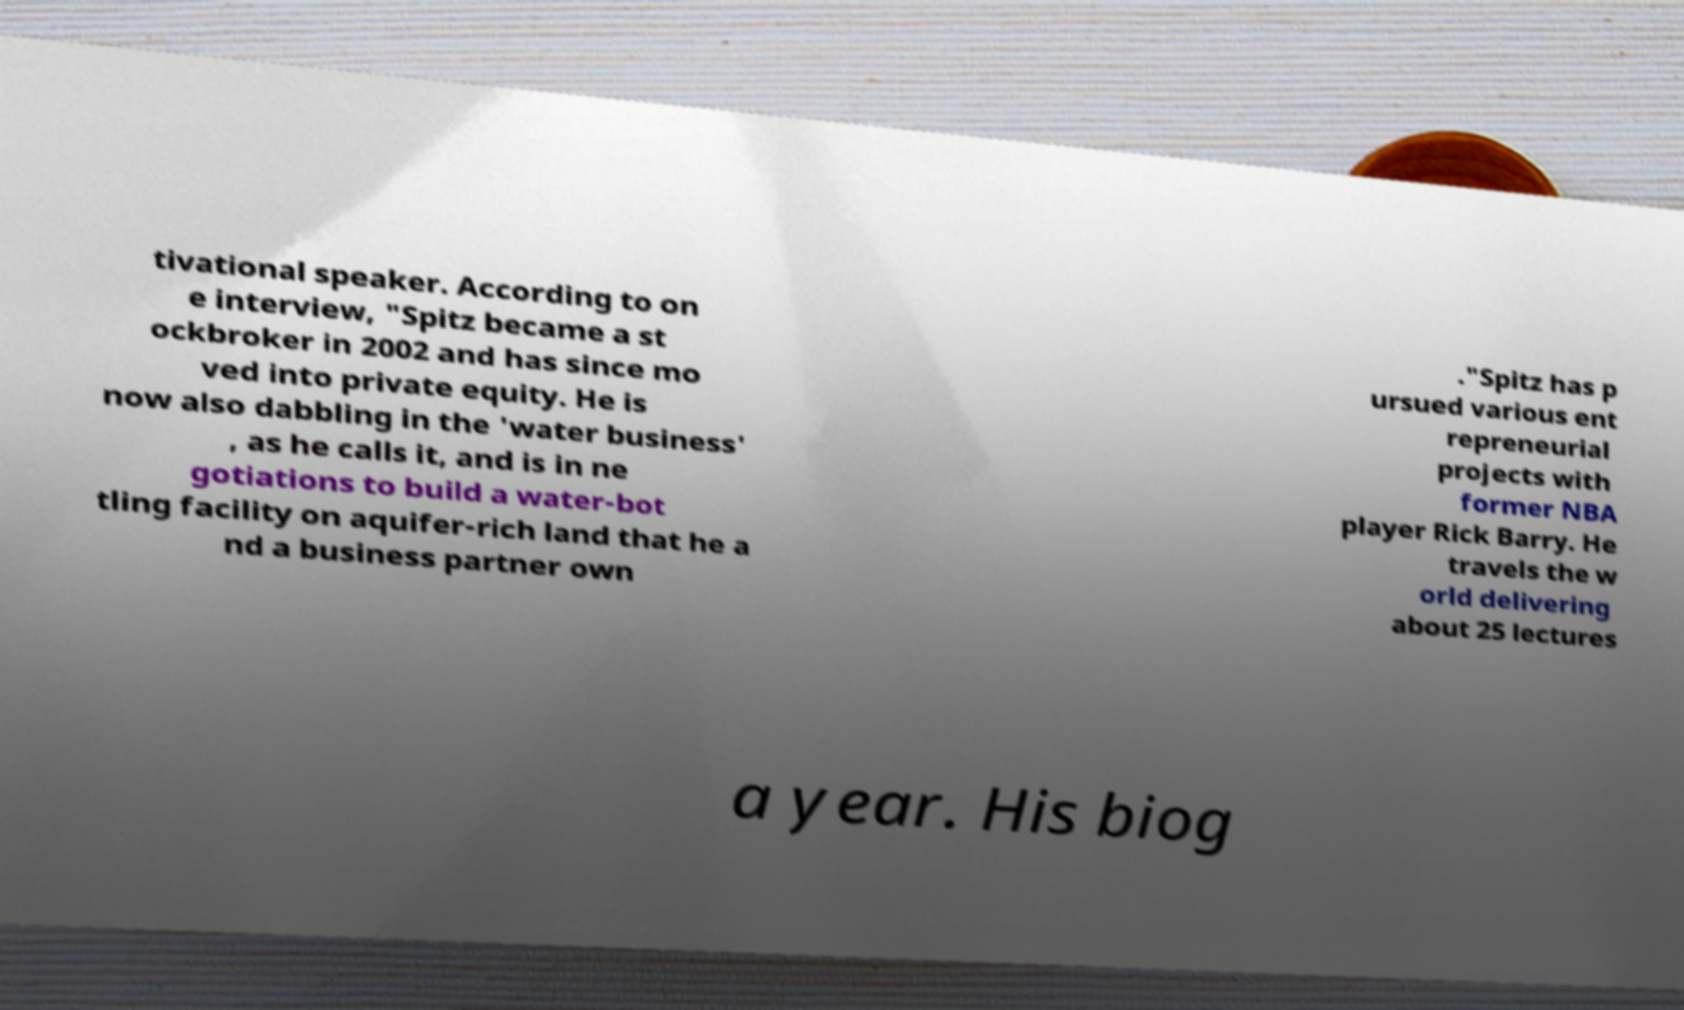Can you read and provide the text displayed in the image?This photo seems to have some interesting text. Can you extract and type it out for me? tivational speaker. According to on e interview, "Spitz became a st ockbroker in 2002 and has since mo ved into private equity. He is now also dabbling in the 'water business' , as he calls it, and is in ne gotiations to build a water-bot tling facility on aquifer-rich land that he a nd a business partner own ."Spitz has p ursued various ent repreneurial projects with former NBA player Rick Barry. He travels the w orld delivering about 25 lectures a year. His biog 